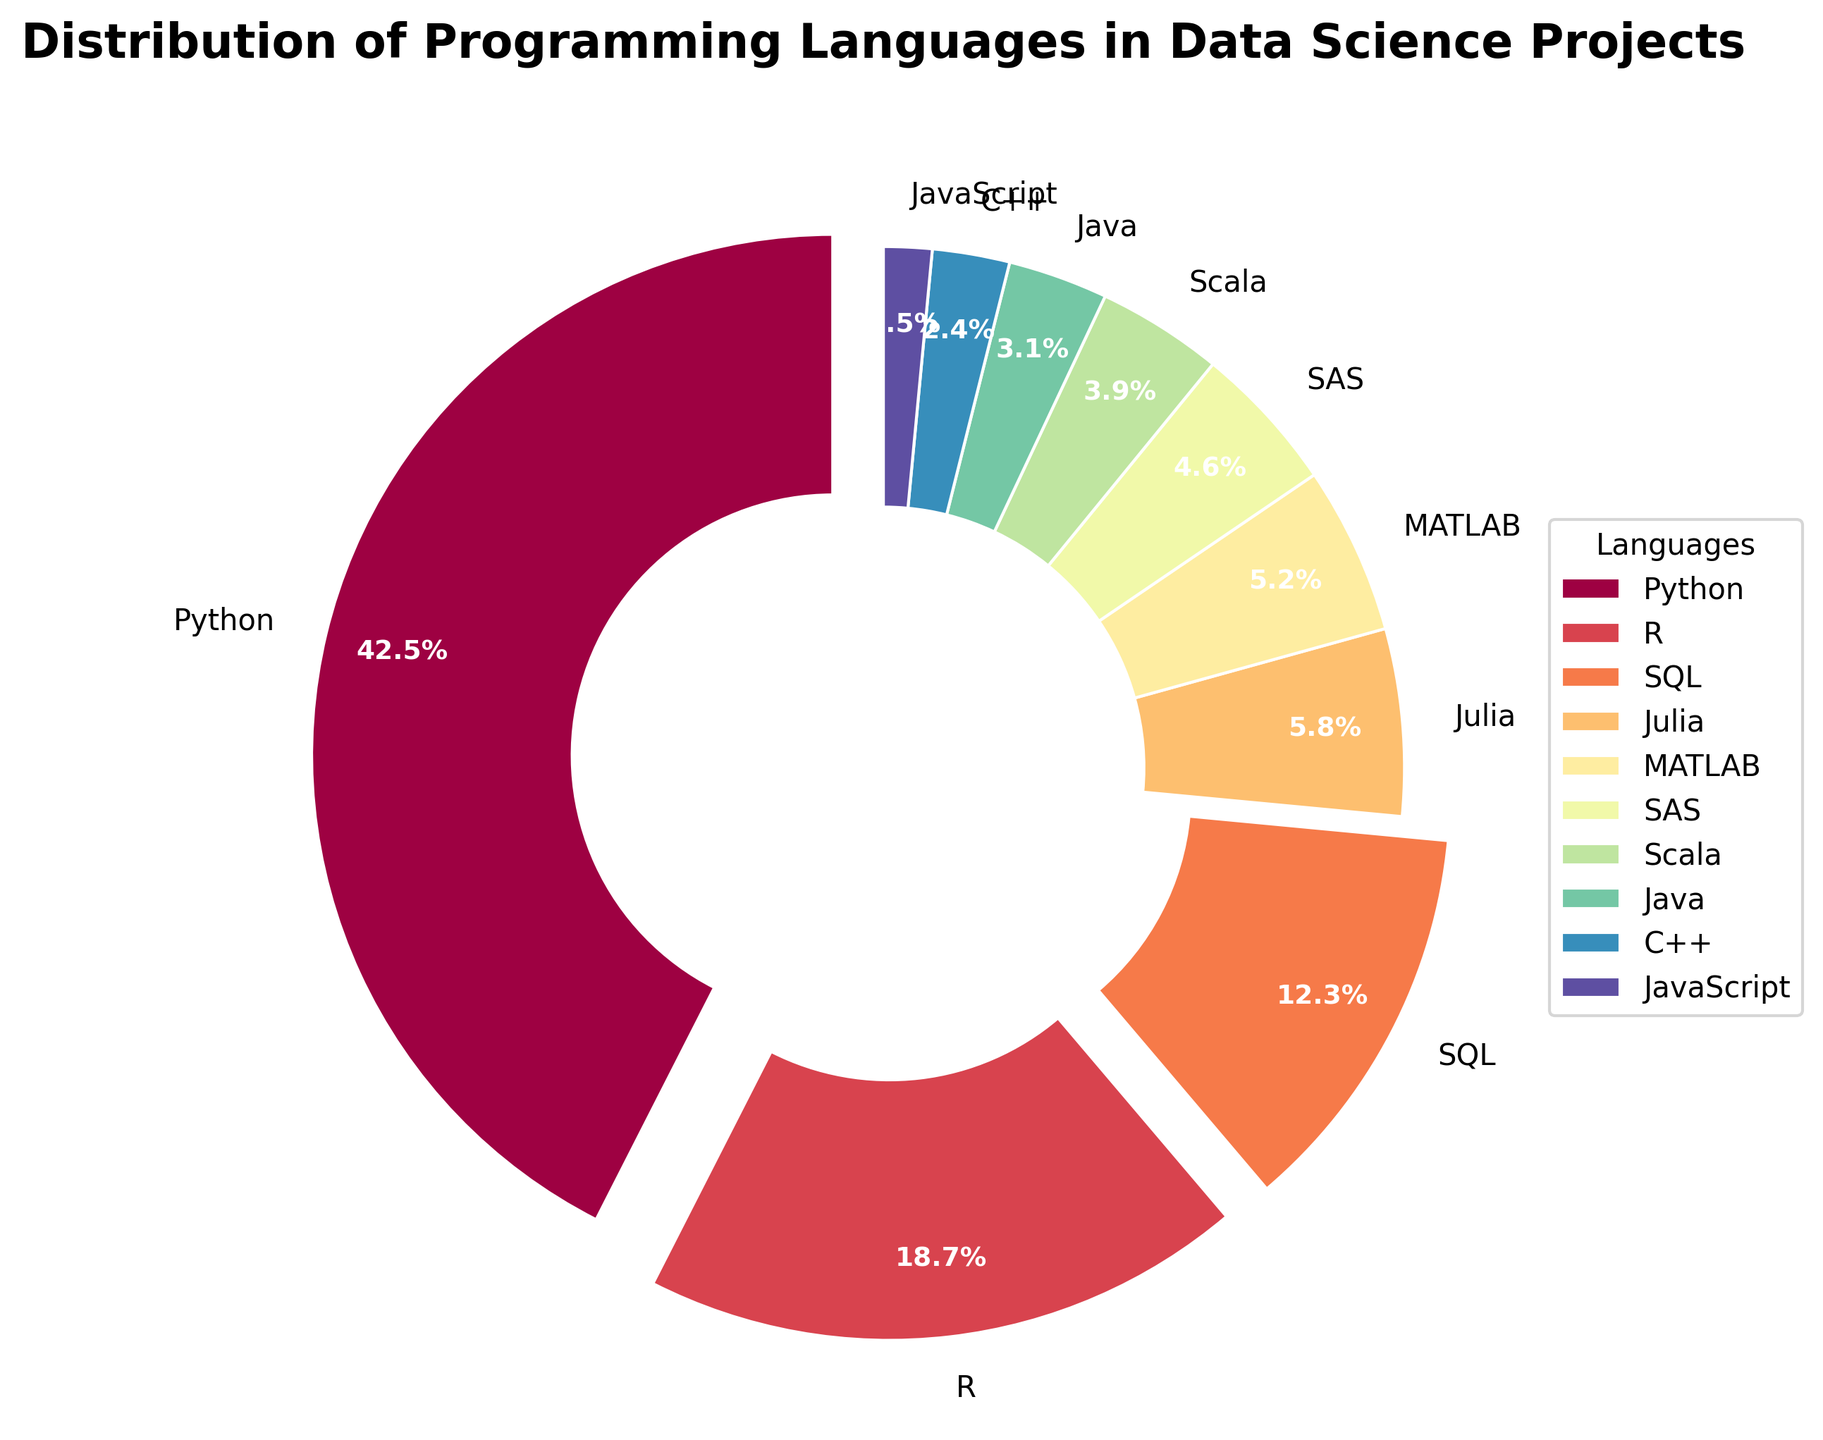what is the language with the highest percentage and what is that percentage? The language with the highest percentage can be determined by identifying the largest wedge in the pie chart. According to the data, Python has the largest share, specifically 42.5%.
Answer: Python, 42.5% what are the total percentages of the top three languages combined? To find the total percentage of the top three languages, sum the percentages of Python (42.5%), R (18.7%), and SQL (12.3%). This gives 42.5 + 18.7 + 12.3 = 73.5.
Answer: 73.5% How does the proportion of Python compare to that of Java? Compare the percentage of Python (42.5%) and Java (3.1%). Python's proportion is significantly higher. Subtracting Java's percentage from Python's percentage gives 42.5 - 3.1 = 39.4.
Answer: Python is 39.4% more than Java Which languages have less than 5% distribution? By checking the legend for wedges with less than 5% labels, we identify MATLAB (5.2) as just above, and SAS (4.6), Scala (3.9), Java (3.1), C++ (2.4), and JavaScript (1.5) as below 5%.
Answer: SAS, Scala, Java, C++, JavaScript What is the combined share of all languages other than Python and R? To find this, sum all percentages except those of Python (42.5%) and R (18.7%). This gives 12.3 + 5.8 + 5.2 + 4.6 + 3.9 + 3.1 + 2.4 + 1.5 = 38.8.
Answer: 38.8% Which language category is in the smallest proportion, and what is its percentage? Identify the smallest wedge by visual inspection, which corresponds to JavaScript and has a percentage of 1.5%.
Answer: JavaScript, 1.5% What's the difference in percentage between SQL and Julia? Subtract Julia's percentage (5.8%) from SQL's percentage (12.3%). This results in 12.3 - 5.8 = 6.5.
Answer: 6.5% How many languages have a percentage greater than 10%? By identifying wedges over 10% in the pie chart, we see two such languages: Python and R.
Answer: 2 What color represents the language with 3.9% distribution? Inspect the pie chart for the wedge labeled with 3.9% (Scala) and note its color corresponding to the legend. This color information helps answer the question.
Answer: Check the plot for color (Spectral color palette - likely blue or green, but confirm by visual inspection of the chart) Overall, what insights can you draw from the distribution of programming languages shown in the chart? The chart shows Python dominates by a large margin in data science projects (42.5%), followed by R and SQL. Most languages have much smaller shares, with JavaScript, Scala, and C++ being some of the least used. This indicates a strong preference for Python and might suggest the need for data scientists to prioritize learning it.
Answer: Python is dominant; R and SQL are also significant; many languages have much smaller shares 